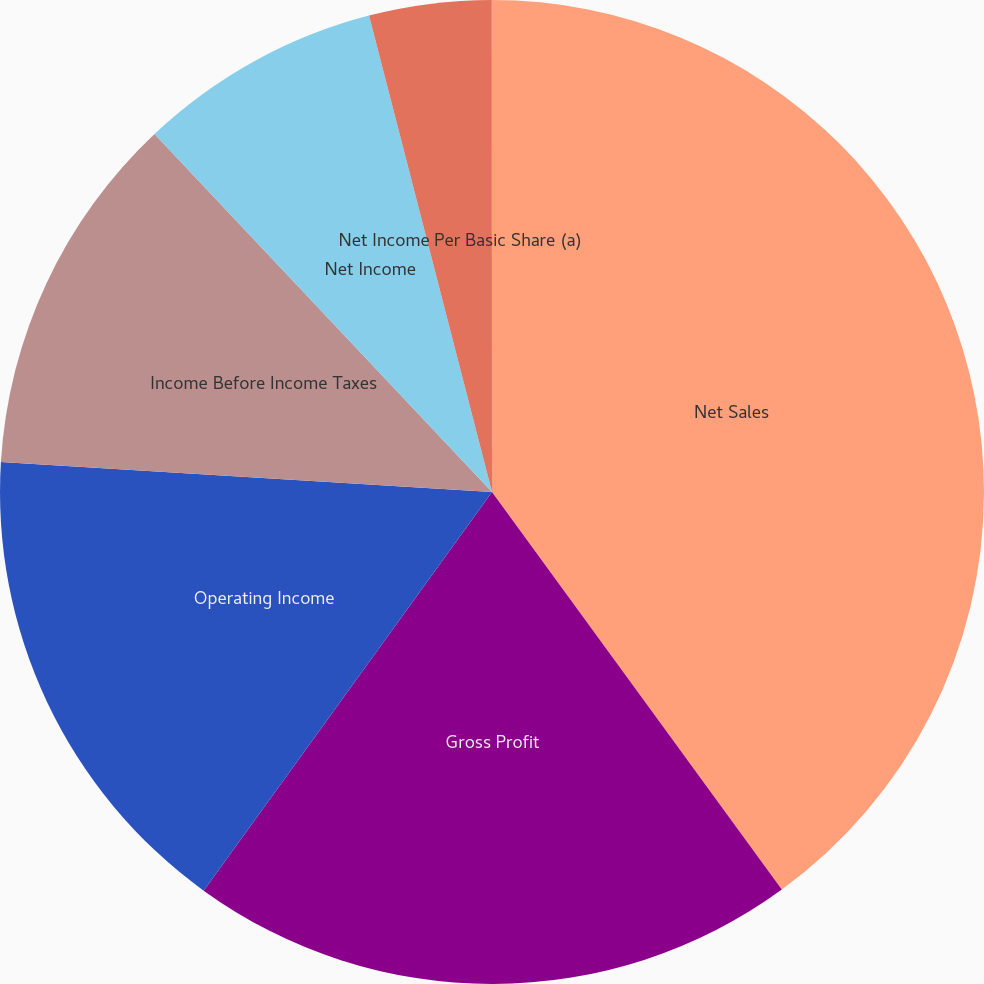Convert chart to OTSL. <chart><loc_0><loc_0><loc_500><loc_500><pie_chart><fcel>Net Sales<fcel>Gross Profit<fcel>Operating Income<fcel>Income Before Income Taxes<fcel>Net Income<fcel>Net Income Per Basic Share (a)<fcel>Net Income Per Diluted Share<nl><fcel>39.97%<fcel>19.99%<fcel>16.0%<fcel>12.0%<fcel>8.01%<fcel>4.01%<fcel>0.01%<nl></chart> 